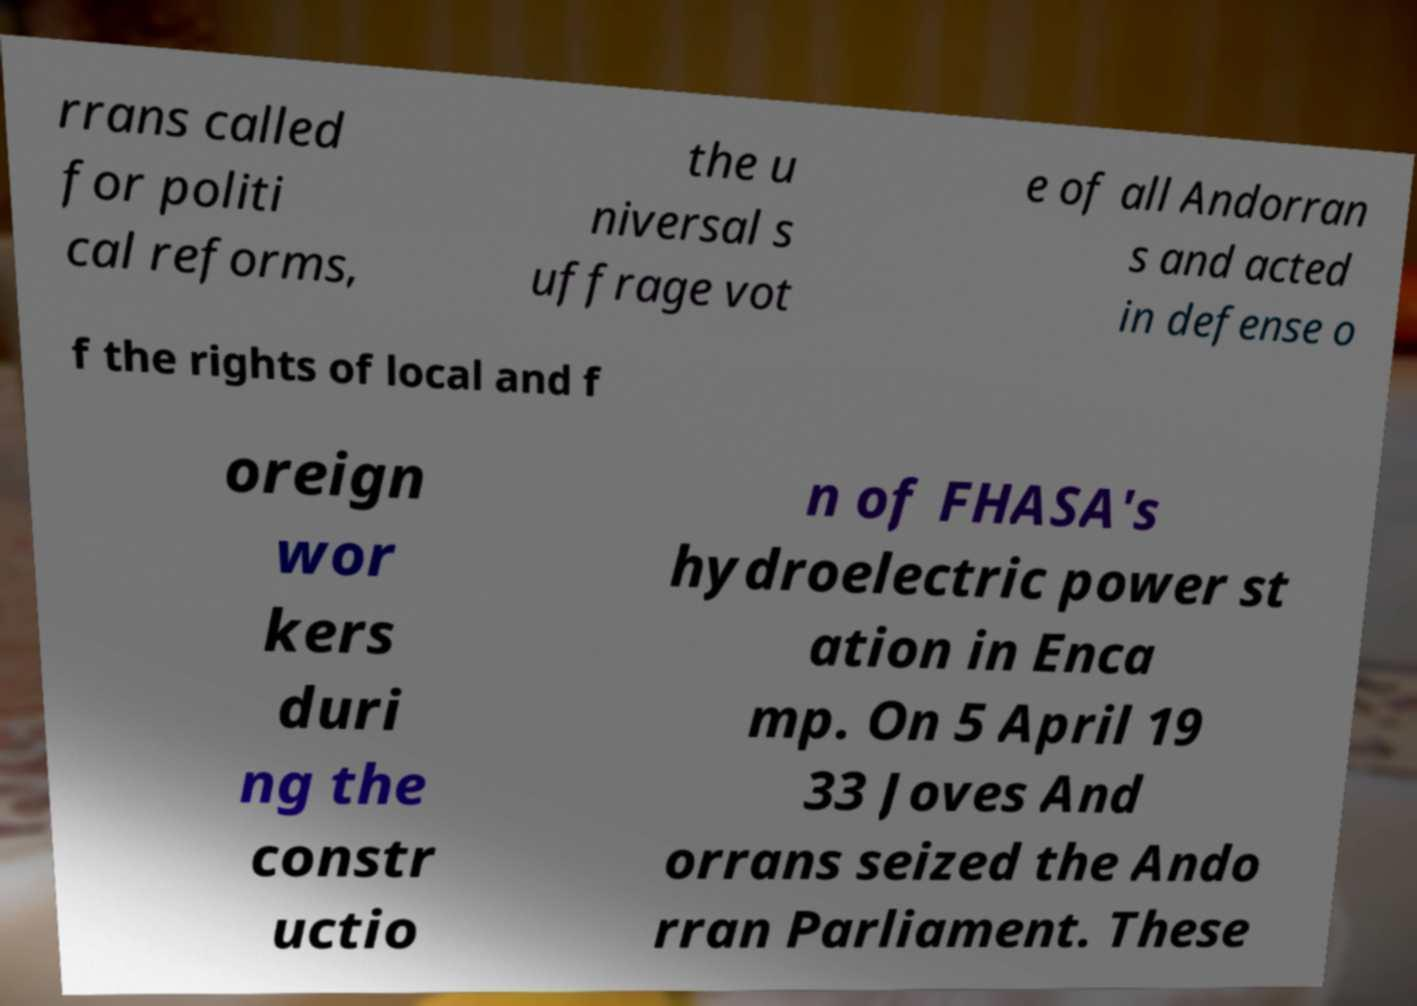Could you assist in decoding the text presented in this image and type it out clearly? rrans called for politi cal reforms, the u niversal s uffrage vot e of all Andorran s and acted in defense o f the rights of local and f oreign wor kers duri ng the constr uctio n of FHASA's hydroelectric power st ation in Enca mp. On 5 April 19 33 Joves And orrans seized the Ando rran Parliament. These 